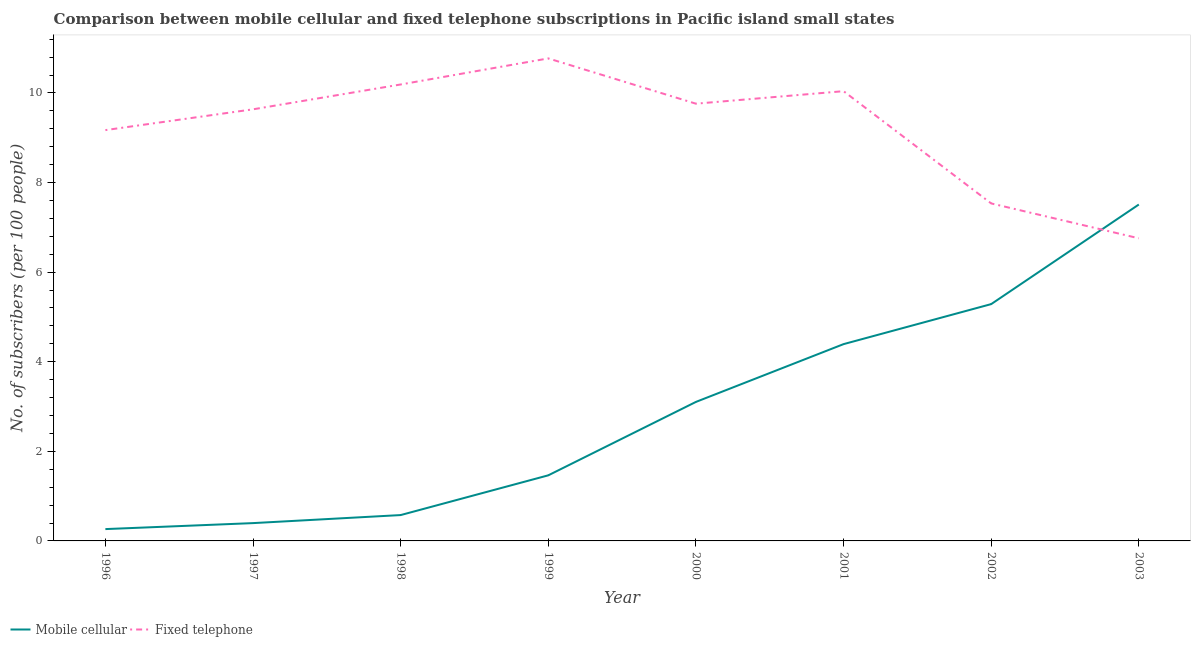What is the number of mobile cellular subscribers in 1996?
Your answer should be compact. 0.26. Across all years, what is the maximum number of mobile cellular subscribers?
Ensure brevity in your answer.  7.51. Across all years, what is the minimum number of mobile cellular subscribers?
Offer a terse response. 0.26. What is the total number of fixed telephone subscribers in the graph?
Ensure brevity in your answer.  73.86. What is the difference between the number of fixed telephone subscribers in 2001 and that in 2003?
Keep it short and to the point. 3.28. What is the difference between the number of mobile cellular subscribers in 2002 and the number of fixed telephone subscribers in 2000?
Your answer should be compact. -4.47. What is the average number of mobile cellular subscribers per year?
Give a very brief answer. 2.87. In the year 2003, what is the difference between the number of mobile cellular subscribers and number of fixed telephone subscribers?
Your response must be concise. 0.75. In how many years, is the number of mobile cellular subscribers greater than 0.8?
Provide a succinct answer. 5. What is the ratio of the number of fixed telephone subscribers in 1997 to that in 1999?
Provide a succinct answer. 0.89. What is the difference between the highest and the second highest number of fixed telephone subscribers?
Ensure brevity in your answer.  0.58. What is the difference between the highest and the lowest number of fixed telephone subscribers?
Provide a succinct answer. 4.02. In how many years, is the number of fixed telephone subscribers greater than the average number of fixed telephone subscribers taken over all years?
Give a very brief answer. 5. Is the sum of the number of mobile cellular subscribers in 2001 and 2003 greater than the maximum number of fixed telephone subscribers across all years?
Provide a succinct answer. Yes. How many years are there in the graph?
Make the answer very short. 8. What is the difference between two consecutive major ticks on the Y-axis?
Provide a short and direct response. 2. Does the graph contain grids?
Offer a very short reply. No. Where does the legend appear in the graph?
Offer a very short reply. Bottom left. How many legend labels are there?
Your answer should be very brief. 2. What is the title of the graph?
Make the answer very short. Comparison between mobile cellular and fixed telephone subscriptions in Pacific island small states. Does "Private creditors" appear as one of the legend labels in the graph?
Offer a terse response. No. What is the label or title of the Y-axis?
Your response must be concise. No. of subscribers (per 100 people). What is the No. of subscribers (per 100 people) in Mobile cellular in 1996?
Your response must be concise. 0.26. What is the No. of subscribers (per 100 people) of Fixed telephone in 1996?
Give a very brief answer. 9.17. What is the No. of subscribers (per 100 people) of Mobile cellular in 1997?
Your response must be concise. 0.4. What is the No. of subscribers (per 100 people) of Fixed telephone in 1997?
Your answer should be very brief. 9.64. What is the No. of subscribers (per 100 people) of Mobile cellular in 1998?
Make the answer very short. 0.58. What is the No. of subscribers (per 100 people) in Fixed telephone in 1998?
Ensure brevity in your answer.  10.19. What is the No. of subscribers (per 100 people) of Mobile cellular in 1999?
Keep it short and to the point. 1.46. What is the No. of subscribers (per 100 people) of Fixed telephone in 1999?
Your answer should be very brief. 10.77. What is the No. of subscribers (per 100 people) in Mobile cellular in 2000?
Your response must be concise. 3.1. What is the No. of subscribers (per 100 people) of Fixed telephone in 2000?
Give a very brief answer. 9.76. What is the No. of subscribers (per 100 people) in Mobile cellular in 2001?
Give a very brief answer. 4.39. What is the No. of subscribers (per 100 people) in Fixed telephone in 2001?
Ensure brevity in your answer.  10.04. What is the No. of subscribers (per 100 people) of Mobile cellular in 2002?
Offer a terse response. 5.29. What is the No. of subscribers (per 100 people) in Fixed telephone in 2002?
Ensure brevity in your answer.  7.53. What is the No. of subscribers (per 100 people) of Mobile cellular in 2003?
Offer a terse response. 7.51. What is the No. of subscribers (per 100 people) of Fixed telephone in 2003?
Your answer should be compact. 6.76. Across all years, what is the maximum No. of subscribers (per 100 people) of Mobile cellular?
Your answer should be compact. 7.51. Across all years, what is the maximum No. of subscribers (per 100 people) of Fixed telephone?
Offer a very short reply. 10.77. Across all years, what is the minimum No. of subscribers (per 100 people) in Mobile cellular?
Your answer should be compact. 0.26. Across all years, what is the minimum No. of subscribers (per 100 people) in Fixed telephone?
Give a very brief answer. 6.76. What is the total No. of subscribers (per 100 people) of Mobile cellular in the graph?
Offer a terse response. 23. What is the total No. of subscribers (per 100 people) in Fixed telephone in the graph?
Provide a succinct answer. 73.86. What is the difference between the No. of subscribers (per 100 people) in Mobile cellular in 1996 and that in 1997?
Provide a short and direct response. -0.13. What is the difference between the No. of subscribers (per 100 people) in Fixed telephone in 1996 and that in 1997?
Keep it short and to the point. -0.46. What is the difference between the No. of subscribers (per 100 people) of Mobile cellular in 1996 and that in 1998?
Your answer should be compact. -0.31. What is the difference between the No. of subscribers (per 100 people) in Fixed telephone in 1996 and that in 1998?
Your response must be concise. -1.02. What is the difference between the No. of subscribers (per 100 people) of Mobile cellular in 1996 and that in 1999?
Provide a short and direct response. -1.2. What is the difference between the No. of subscribers (per 100 people) in Fixed telephone in 1996 and that in 1999?
Your answer should be compact. -1.6. What is the difference between the No. of subscribers (per 100 people) of Mobile cellular in 1996 and that in 2000?
Ensure brevity in your answer.  -2.84. What is the difference between the No. of subscribers (per 100 people) of Fixed telephone in 1996 and that in 2000?
Make the answer very short. -0.59. What is the difference between the No. of subscribers (per 100 people) of Mobile cellular in 1996 and that in 2001?
Provide a short and direct response. -4.13. What is the difference between the No. of subscribers (per 100 people) in Fixed telephone in 1996 and that in 2001?
Ensure brevity in your answer.  -0.87. What is the difference between the No. of subscribers (per 100 people) in Mobile cellular in 1996 and that in 2002?
Provide a short and direct response. -5.02. What is the difference between the No. of subscribers (per 100 people) of Fixed telephone in 1996 and that in 2002?
Offer a very short reply. 1.64. What is the difference between the No. of subscribers (per 100 people) in Mobile cellular in 1996 and that in 2003?
Give a very brief answer. -7.25. What is the difference between the No. of subscribers (per 100 people) of Fixed telephone in 1996 and that in 2003?
Your response must be concise. 2.42. What is the difference between the No. of subscribers (per 100 people) of Mobile cellular in 1997 and that in 1998?
Give a very brief answer. -0.18. What is the difference between the No. of subscribers (per 100 people) in Fixed telephone in 1997 and that in 1998?
Keep it short and to the point. -0.55. What is the difference between the No. of subscribers (per 100 people) of Mobile cellular in 1997 and that in 1999?
Your answer should be compact. -1.07. What is the difference between the No. of subscribers (per 100 people) of Fixed telephone in 1997 and that in 1999?
Provide a succinct answer. -1.14. What is the difference between the No. of subscribers (per 100 people) of Mobile cellular in 1997 and that in 2000?
Keep it short and to the point. -2.71. What is the difference between the No. of subscribers (per 100 people) of Fixed telephone in 1997 and that in 2000?
Ensure brevity in your answer.  -0.13. What is the difference between the No. of subscribers (per 100 people) of Mobile cellular in 1997 and that in 2001?
Provide a succinct answer. -4. What is the difference between the No. of subscribers (per 100 people) of Fixed telephone in 1997 and that in 2001?
Keep it short and to the point. -0.41. What is the difference between the No. of subscribers (per 100 people) of Mobile cellular in 1997 and that in 2002?
Ensure brevity in your answer.  -4.89. What is the difference between the No. of subscribers (per 100 people) in Fixed telephone in 1997 and that in 2002?
Offer a terse response. 2.1. What is the difference between the No. of subscribers (per 100 people) in Mobile cellular in 1997 and that in 2003?
Your answer should be compact. -7.11. What is the difference between the No. of subscribers (per 100 people) of Fixed telephone in 1997 and that in 2003?
Keep it short and to the point. 2.88. What is the difference between the No. of subscribers (per 100 people) of Mobile cellular in 1998 and that in 1999?
Offer a very short reply. -0.89. What is the difference between the No. of subscribers (per 100 people) in Fixed telephone in 1998 and that in 1999?
Offer a terse response. -0.58. What is the difference between the No. of subscribers (per 100 people) in Mobile cellular in 1998 and that in 2000?
Give a very brief answer. -2.53. What is the difference between the No. of subscribers (per 100 people) in Fixed telephone in 1998 and that in 2000?
Ensure brevity in your answer.  0.43. What is the difference between the No. of subscribers (per 100 people) of Mobile cellular in 1998 and that in 2001?
Keep it short and to the point. -3.82. What is the difference between the No. of subscribers (per 100 people) in Fixed telephone in 1998 and that in 2001?
Provide a short and direct response. 0.15. What is the difference between the No. of subscribers (per 100 people) in Mobile cellular in 1998 and that in 2002?
Ensure brevity in your answer.  -4.71. What is the difference between the No. of subscribers (per 100 people) in Fixed telephone in 1998 and that in 2002?
Give a very brief answer. 2.66. What is the difference between the No. of subscribers (per 100 people) of Mobile cellular in 1998 and that in 2003?
Give a very brief answer. -6.93. What is the difference between the No. of subscribers (per 100 people) in Fixed telephone in 1998 and that in 2003?
Provide a succinct answer. 3.43. What is the difference between the No. of subscribers (per 100 people) of Mobile cellular in 1999 and that in 2000?
Offer a very short reply. -1.64. What is the difference between the No. of subscribers (per 100 people) in Fixed telephone in 1999 and that in 2000?
Give a very brief answer. 1.01. What is the difference between the No. of subscribers (per 100 people) in Mobile cellular in 1999 and that in 2001?
Make the answer very short. -2.93. What is the difference between the No. of subscribers (per 100 people) of Fixed telephone in 1999 and that in 2001?
Make the answer very short. 0.73. What is the difference between the No. of subscribers (per 100 people) in Mobile cellular in 1999 and that in 2002?
Your response must be concise. -3.82. What is the difference between the No. of subscribers (per 100 people) in Fixed telephone in 1999 and that in 2002?
Make the answer very short. 3.24. What is the difference between the No. of subscribers (per 100 people) in Mobile cellular in 1999 and that in 2003?
Make the answer very short. -6.05. What is the difference between the No. of subscribers (per 100 people) in Fixed telephone in 1999 and that in 2003?
Provide a short and direct response. 4.02. What is the difference between the No. of subscribers (per 100 people) in Mobile cellular in 2000 and that in 2001?
Give a very brief answer. -1.29. What is the difference between the No. of subscribers (per 100 people) in Fixed telephone in 2000 and that in 2001?
Your response must be concise. -0.28. What is the difference between the No. of subscribers (per 100 people) of Mobile cellular in 2000 and that in 2002?
Make the answer very short. -2.18. What is the difference between the No. of subscribers (per 100 people) in Fixed telephone in 2000 and that in 2002?
Ensure brevity in your answer.  2.23. What is the difference between the No. of subscribers (per 100 people) in Mobile cellular in 2000 and that in 2003?
Your response must be concise. -4.41. What is the difference between the No. of subscribers (per 100 people) of Fixed telephone in 2000 and that in 2003?
Your response must be concise. 3.01. What is the difference between the No. of subscribers (per 100 people) in Mobile cellular in 2001 and that in 2002?
Ensure brevity in your answer.  -0.89. What is the difference between the No. of subscribers (per 100 people) in Fixed telephone in 2001 and that in 2002?
Your answer should be compact. 2.51. What is the difference between the No. of subscribers (per 100 people) of Mobile cellular in 2001 and that in 2003?
Provide a short and direct response. -3.12. What is the difference between the No. of subscribers (per 100 people) of Fixed telephone in 2001 and that in 2003?
Offer a very short reply. 3.28. What is the difference between the No. of subscribers (per 100 people) in Mobile cellular in 2002 and that in 2003?
Ensure brevity in your answer.  -2.22. What is the difference between the No. of subscribers (per 100 people) in Fixed telephone in 2002 and that in 2003?
Keep it short and to the point. 0.78. What is the difference between the No. of subscribers (per 100 people) of Mobile cellular in 1996 and the No. of subscribers (per 100 people) of Fixed telephone in 1997?
Provide a succinct answer. -9.37. What is the difference between the No. of subscribers (per 100 people) in Mobile cellular in 1996 and the No. of subscribers (per 100 people) in Fixed telephone in 1998?
Ensure brevity in your answer.  -9.93. What is the difference between the No. of subscribers (per 100 people) of Mobile cellular in 1996 and the No. of subscribers (per 100 people) of Fixed telephone in 1999?
Provide a short and direct response. -10.51. What is the difference between the No. of subscribers (per 100 people) of Mobile cellular in 1996 and the No. of subscribers (per 100 people) of Fixed telephone in 2000?
Ensure brevity in your answer.  -9.5. What is the difference between the No. of subscribers (per 100 people) in Mobile cellular in 1996 and the No. of subscribers (per 100 people) in Fixed telephone in 2001?
Provide a short and direct response. -9.78. What is the difference between the No. of subscribers (per 100 people) in Mobile cellular in 1996 and the No. of subscribers (per 100 people) in Fixed telephone in 2002?
Keep it short and to the point. -7.27. What is the difference between the No. of subscribers (per 100 people) in Mobile cellular in 1996 and the No. of subscribers (per 100 people) in Fixed telephone in 2003?
Provide a short and direct response. -6.49. What is the difference between the No. of subscribers (per 100 people) of Mobile cellular in 1997 and the No. of subscribers (per 100 people) of Fixed telephone in 1998?
Your answer should be very brief. -9.79. What is the difference between the No. of subscribers (per 100 people) of Mobile cellular in 1997 and the No. of subscribers (per 100 people) of Fixed telephone in 1999?
Keep it short and to the point. -10.37. What is the difference between the No. of subscribers (per 100 people) in Mobile cellular in 1997 and the No. of subscribers (per 100 people) in Fixed telephone in 2000?
Offer a terse response. -9.36. What is the difference between the No. of subscribers (per 100 people) of Mobile cellular in 1997 and the No. of subscribers (per 100 people) of Fixed telephone in 2001?
Provide a succinct answer. -9.64. What is the difference between the No. of subscribers (per 100 people) of Mobile cellular in 1997 and the No. of subscribers (per 100 people) of Fixed telephone in 2002?
Ensure brevity in your answer.  -7.14. What is the difference between the No. of subscribers (per 100 people) of Mobile cellular in 1997 and the No. of subscribers (per 100 people) of Fixed telephone in 2003?
Offer a very short reply. -6.36. What is the difference between the No. of subscribers (per 100 people) in Mobile cellular in 1998 and the No. of subscribers (per 100 people) in Fixed telephone in 1999?
Provide a succinct answer. -10.19. What is the difference between the No. of subscribers (per 100 people) in Mobile cellular in 1998 and the No. of subscribers (per 100 people) in Fixed telephone in 2000?
Your answer should be compact. -9.18. What is the difference between the No. of subscribers (per 100 people) of Mobile cellular in 1998 and the No. of subscribers (per 100 people) of Fixed telephone in 2001?
Offer a terse response. -9.46. What is the difference between the No. of subscribers (per 100 people) of Mobile cellular in 1998 and the No. of subscribers (per 100 people) of Fixed telephone in 2002?
Provide a succinct answer. -6.96. What is the difference between the No. of subscribers (per 100 people) of Mobile cellular in 1998 and the No. of subscribers (per 100 people) of Fixed telephone in 2003?
Offer a very short reply. -6.18. What is the difference between the No. of subscribers (per 100 people) of Mobile cellular in 1999 and the No. of subscribers (per 100 people) of Fixed telephone in 2000?
Provide a short and direct response. -8.3. What is the difference between the No. of subscribers (per 100 people) of Mobile cellular in 1999 and the No. of subscribers (per 100 people) of Fixed telephone in 2001?
Keep it short and to the point. -8.58. What is the difference between the No. of subscribers (per 100 people) of Mobile cellular in 1999 and the No. of subscribers (per 100 people) of Fixed telephone in 2002?
Keep it short and to the point. -6.07. What is the difference between the No. of subscribers (per 100 people) of Mobile cellular in 1999 and the No. of subscribers (per 100 people) of Fixed telephone in 2003?
Ensure brevity in your answer.  -5.29. What is the difference between the No. of subscribers (per 100 people) of Mobile cellular in 2000 and the No. of subscribers (per 100 people) of Fixed telephone in 2001?
Make the answer very short. -6.94. What is the difference between the No. of subscribers (per 100 people) of Mobile cellular in 2000 and the No. of subscribers (per 100 people) of Fixed telephone in 2002?
Offer a terse response. -4.43. What is the difference between the No. of subscribers (per 100 people) of Mobile cellular in 2000 and the No. of subscribers (per 100 people) of Fixed telephone in 2003?
Make the answer very short. -3.65. What is the difference between the No. of subscribers (per 100 people) of Mobile cellular in 2001 and the No. of subscribers (per 100 people) of Fixed telephone in 2002?
Keep it short and to the point. -3.14. What is the difference between the No. of subscribers (per 100 people) of Mobile cellular in 2001 and the No. of subscribers (per 100 people) of Fixed telephone in 2003?
Give a very brief answer. -2.36. What is the difference between the No. of subscribers (per 100 people) in Mobile cellular in 2002 and the No. of subscribers (per 100 people) in Fixed telephone in 2003?
Your answer should be very brief. -1.47. What is the average No. of subscribers (per 100 people) in Mobile cellular per year?
Your answer should be compact. 2.87. What is the average No. of subscribers (per 100 people) of Fixed telephone per year?
Make the answer very short. 9.23. In the year 1996, what is the difference between the No. of subscribers (per 100 people) in Mobile cellular and No. of subscribers (per 100 people) in Fixed telephone?
Offer a very short reply. -8.91. In the year 1997, what is the difference between the No. of subscribers (per 100 people) in Mobile cellular and No. of subscribers (per 100 people) in Fixed telephone?
Make the answer very short. -9.24. In the year 1998, what is the difference between the No. of subscribers (per 100 people) of Mobile cellular and No. of subscribers (per 100 people) of Fixed telephone?
Make the answer very short. -9.61. In the year 1999, what is the difference between the No. of subscribers (per 100 people) in Mobile cellular and No. of subscribers (per 100 people) in Fixed telephone?
Your answer should be compact. -9.31. In the year 2000, what is the difference between the No. of subscribers (per 100 people) in Mobile cellular and No. of subscribers (per 100 people) in Fixed telephone?
Give a very brief answer. -6.66. In the year 2001, what is the difference between the No. of subscribers (per 100 people) of Mobile cellular and No. of subscribers (per 100 people) of Fixed telephone?
Make the answer very short. -5.65. In the year 2002, what is the difference between the No. of subscribers (per 100 people) of Mobile cellular and No. of subscribers (per 100 people) of Fixed telephone?
Your answer should be very brief. -2.25. In the year 2003, what is the difference between the No. of subscribers (per 100 people) of Mobile cellular and No. of subscribers (per 100 people) of Fixed telephone?
Keep it short and to the point. 0.75. What is the ratio of the No. of subscribers (per 100 people) of Mobile cellular in 1996 to that in 1997?
Ensure brevity in your answer.  0.66. What is the ratio of the No. of subscribers (per 100 people) of Fixed telephone in 1996 to that in 1997?
Give a very brief answer. 0.95. What is the ratio of the No. of subscribers (per 100 people) of Mobile cellular in 1996 to that in 1998?
Offer a terse response. 0.46. What is the ratio of the No. of subscribers (per 100 people) of Mobile cellular in 1996 to that in 1999?
Offer a very short reply. 0.18. What is the ratio of the No. of subscribers (per 100 people) of Fixed telephone in 1996 to that in 1999?
Keep it short and to the point. 0.85. What is the ratio of the No. of subscribers (per 100 people) of Mobile cellular in 1996 to that in 2000?
Give a very brief answer. 0.09. What is the ratio of the No. of subscribers (per 100 people) in Fixed telephone in 1996 to that in 2000?
Your answer should be very brief. 0.94. What is the ratio of the No. of subscribers (per 100 people) in Mobile cellular in 1996 to that in 2001?
Provide a short and direct response. 0.06. What is the ratio of the No. of subscribers (per 100 people) of Fixed telephone in 1996 to that in 2001?
Provide a succinct answer. 0.91. What is the ratio of the No. of subscribers (per 100 people) of Mobile cellular in 1996 to that in 2002?
Ensure brevity in your answer.  0.05. What is the ratio of the No. of subscribers (per 100 people) of Fixed telephone in 1996 to that in 2002?
Your response must be concise. 1.22. What is the ratio of the No. of subscribers (per 100 people) of Mobile cellular in 1996 to that in 2003?
Provide a short and direct response. 0.04. What is the ratio of the No. of subscribers (per 100 people) in Fixed telephone in 1996 to that in 2003?
Keep it short and to the point. 1.36. What is the ratio of the No. of subscribers (per 100 people) in Mobile cellular in 1997 to that in 1998?
Your answer should be compact. 0.69. What is the ratio of the No. of subscribers (per 100 people) in Fixed telephone in 1997 to that in 1998?
Keep it short and to the point. 0.95. What is the ratio of the No. of subscribers (per 100 people) in Mobile cellular in 1997 to that in 1999?
Provide a short and direct response. 0.27. What is the ratio of the No. of subscribers (per 100 people) of Fixed telephone in 1997 to that in 1999?
Offer a very short reply. 0.89. What is the ratio of the No. of subscribers (per 100 people) in Mobile cellular in 1997 to that in 2000?
Your answer should be very brief. 0.13. What is the ratio of the No. of subscribers (per 100 people) in Fixed telephone in 1997 to that in 2000?
Your response must be concise. 0.99. What is the ratio of the No. of subscribers (per 100 people) of Mobile cellular in 1997 to that in 2001?
Keep it short and to the point. 0.09. What is the ratio of the No. of subscribers (per 100 people) of Fixed telephone in 1997 to that in 2001?
Ensure brevity in your answer.  0.96. What is the ratio of the No. of subscribers (per 100 people) in Mobile cellular in 1997 to that in 2002?
Your answer should be very brief. 0.08. What is the ratio of the No. of subscribers (per 100 people) of Fixed telephone in 1997 to that in 2002?
Provide a short and direct response. 1.28. What is the ratio of the No. of subscribers (per 100 people) of Mobile cellular in 1997 to that in 2003?
Your answer should be compact. 0.05. What is the ratio of the No. of subscribers (per 100 people) of Fixed telephone in 1997 to that in 2003?
Your response must be concise. 1.43. What is the ratio of the No. of subscribers (per 100 people) in Mobile cellular in 1998 to that in 1999?
Provide a succinct answer. 0.39. What is the ratio of the No. of subscribers (per 100 people) in Fixed telephone in 1998 to that in 1999?
Make the answer very short. 0.95. What is the ratio of the No. of subscribers (per 100 people) of Mobile cellular in 1998 to that in 2000?
Offer a very short reply. 0.19. What is the ratio of the No. of subscribers (per 100 people) in Fixed telephone in 1998 to that in 2000?
Give a very brief answer. 1.04. What is the ratio of the No. of subscribers (per 100 people) of Mobile cellular in 1998 to that in 2001?
Provide a succinct answer. 0.13. What is the ratio of the No. of subscribers (per 100 people) in Fixed telephone in 1998 to that in 2001?
Make the answer very short. 1.01. What is the ratio of the No. of subscribers (per 100 people) in Mobile cellular in 1998 to that in 2002?
Your answer should be compact. 0.11. What is the ratio of the No. of subscribers (per 100 people) in Fixed telephone in 1998 to that in 2002?
Give a very brief answer. 1.35. What is the ratio of the No. of subscribers (per 100 people) in Mobile cellular in 1998 to that in 2003?
Ensure brevity in your answer.  0.08. What is the ratio of the No. of subscribers (per 100 people) in Fixed telephone in 1998 to that in 2003?
Ensure brevity in your answer.  1.51. What is the ratio of the No. of subscribers (per 100 people) of Mobile cellular in 1999 to that in 2000?
Give a very brief answer. 0.47. What is the ratio of the No. of subscribers (per 100 people) in Fixed telephone in 1999 to that in 2000?
Give a very brief answer. 1.1. What is the ratio of the No. of subscribers (per 100 people) of Mobile cellular in 1999 to that in 2001?
Ensure brevity in your answer.  0.33. What is the ratio of the No. of subscribers (per 100 people) of Fixed telephone in 1999 to that in 2001?
Offer a very short reply. 1.07. What is the ratio of the No. of subscribers (per 100 people) in Mobile cellular in 1999 to that in 2002?
Provide a short and direct response. 0.28. What is the ratio of the No. of subscribers (per 100 people) in Fixed telephone in 1999 to that in 2002?
Keep it short and to the point. 1.43. What is the ratio of the No. of subscribers (per 100 people) of Mobile cellular in 1999 to that in 2003?
Give a very brief answer. 0.2. What is the ratio of the No. of subscribers (per 100 people) in Fixed telephone in 1999 to that in 2003?
Ensure brevity in your answer.  1.59. What is the ratio of the No. of subscribers (per 100 people) in Mobile cellular in 2000 to that in 2001?
Your response must be concise. 0.71. What is the ratio of the No. of subscribers (per 100 people) of Fixed telephone in 2000 to that in 2001?
Offer a terse response. 0.97. What is the ratio of the No. of subscribers (per 100 people) of Mobile cellular in 2000 to that in 2002?
Make the answer very short. 0.59. What is the ratio of the No. of subscribers (per 100 people) of Fixed telephone in 2000 to that in 2002?
Your answer should be very brief. 1.3. What is the ratio of the No. of subscribers (per 100 people) of Mobile cellular in 2000 to that in 2003?
Ensure brevity in your answer.  0.41. What is the ratio of the No. of subscribers (per 100 people) of Fixed telephone in 2000 to that in 2003?
Your answer should be compact. 1.44. What is the ratio of the No. of subscribers (per 100 people) in Mobile cellular in 2001 to that in 2002?
Offer a very short reply. 0.83. What is the ratio of the No. of subscribers (per 100 people) in Fixed telephone in 2001 to that in 2002?
Ensure brevity in your answer.  1.33. What is the ratio of the No. of subscribers (per 100 people) in Mobile cellular in 2001 to that in 2003?
Ensure brevity in your answer.  0.58. What is the ratio of the No. of subscribers (per 100 people) of Fixed telephone in 2001 to that in 2003?
Your response must be concise. 1.49. What is the ratio of the No. of subscribers (per 100 people) of Mobile cellular in 2002 to that in 2003?
Your answer should be compact. 0.7. What is the ratio of the No. of subscribers (per 100 people) of Fixed telephone in 2002 to that in 2003?
Give a very brief answer. 1.12. What is the difference between the highest and the second highest No. of subscribers (per 100 people) in Mobile cellular?
Provide a short and direct response. 2.22. What is the difference between the highest and the second highest No. of subscribers (per 100 people) in Fixed telephone?
Provide a short and direct response. 0.58. What is the difference between the highest and the lowest No. of subscribers (per 100 people) of Mobile cellular?
Ensure brevity in your answer.  7.25. What is the difference between the highest and the lowest No. of subscribers (per 100 people) in Fixed telephone?
Offer a very short reply. 4.02. 